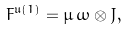Convert formula to latex. <formula><loc_0><loc_0><loc_500><loc_500>F ^ { \mathfrak u ( 1 ) } = \mu \, \omega \otimes J ,</formula> 